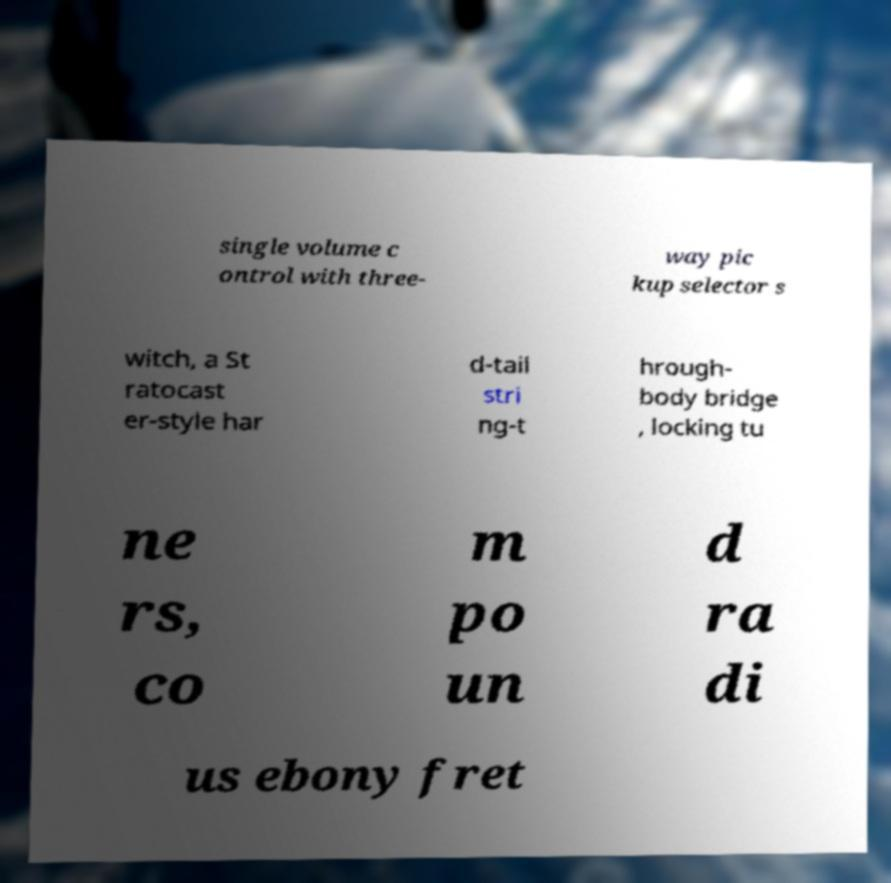Please read and relay the text visible in this image. What does it say? single volume c ontrol with three- way pic kup selector s witch, a St ratocast er-style har d-tail stri ng-t hrough- body bridge , locking tu ne rs, co m po un d ra di us ebony fret 